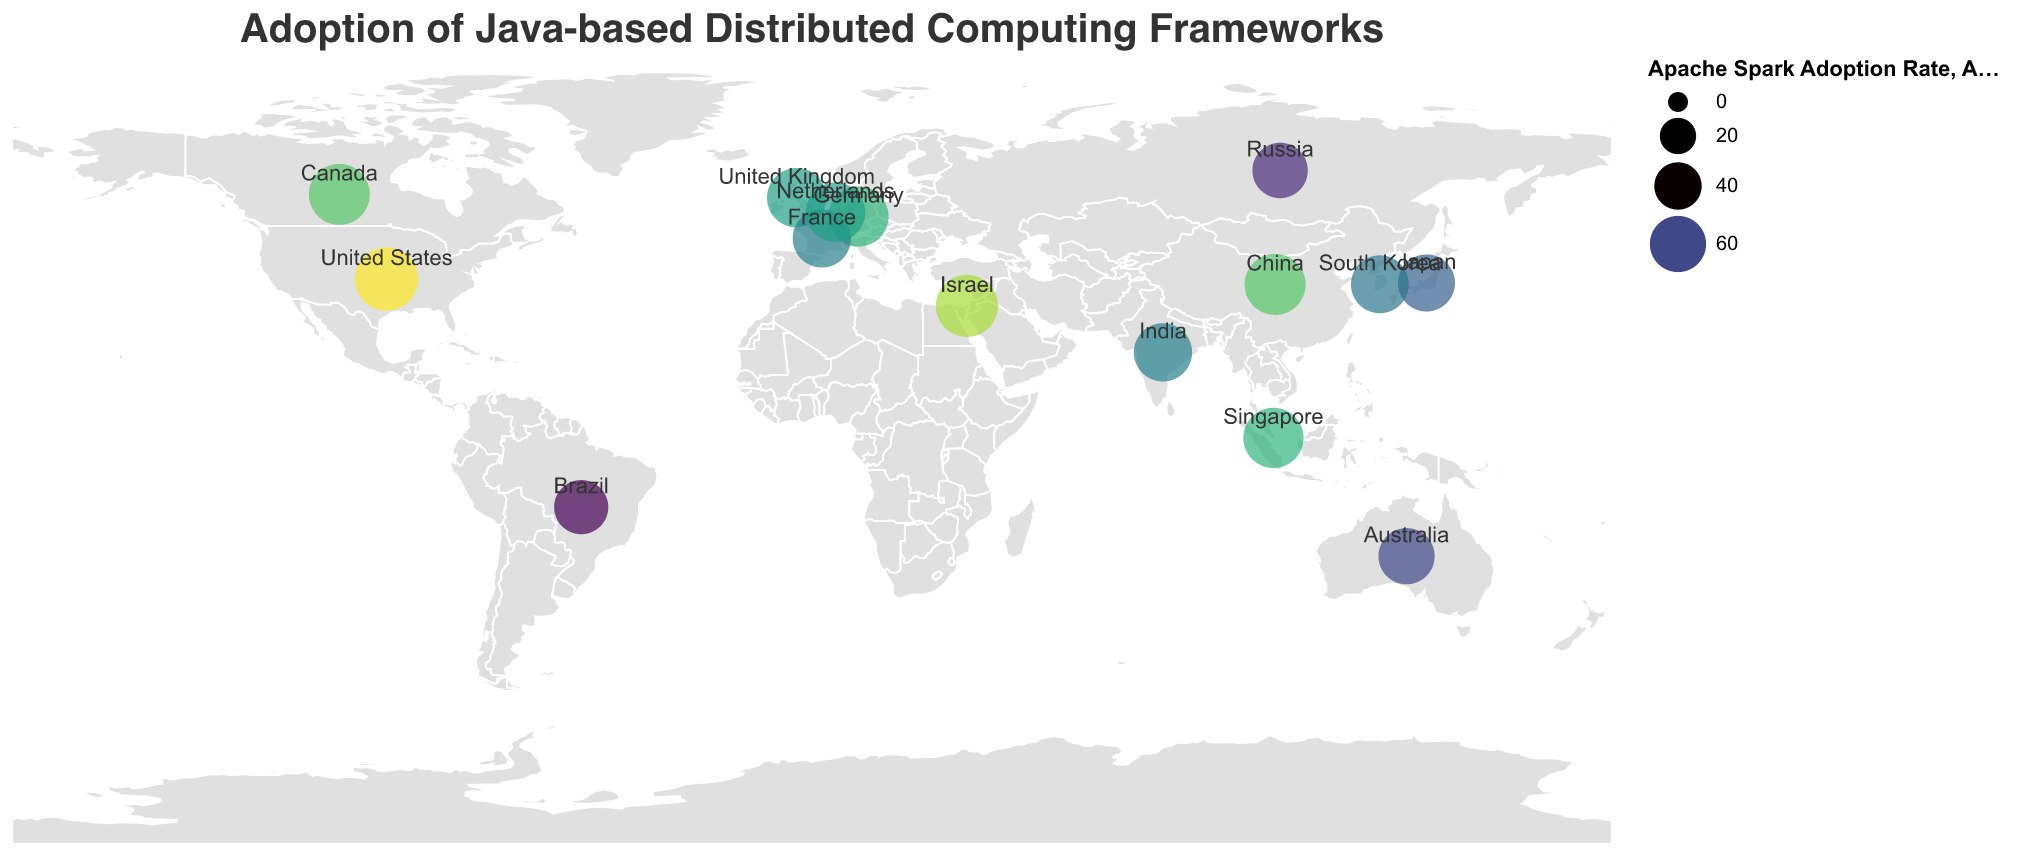What is the title of the figure? The title of the figure is displayed at the top and it reads "Adoption of Java-based Distributed Computing Frameworks".
Answer: Adoption of Java-based Distributed Computing Frameworks Which country has the highest adoption rate of Apache Spark? The country with the highest value represented by the largest circle size and the darkest color in the legend for Apache Spark is visible. The value is 78 for the United States.
Answer: United States What is the average adoption rate of Alluxio across all listed countries? Sum the Alluxio adoption rates for all countries and divide by the number of countries. Calculation: (25 + 30 + 22 + 28 + 20 + 18 + 15 + 22 + 24 + 18 + 26 + 20 + 24 + 20 + 28) / 15 = 340 / 15 = 22.67.
Answer: 22.67 Which two countries have the same adoption rate for Apache Storm? By looking at the numerical labels on the figure, United Kingdom and China both have a value of 38 for Apache Storm.
Answer: United Kingdom and China What is the difference between the highest and the lowest adoption rates of Apache Hadoop? Identify the highest value (China, 70) and the lowest value (France, 52) from the figure, then calculate the difference: 70 - 52 = 18.
Answer: 18 Which country has a higher adoption rate of Apache Flink, Germany or Australia? By comparing the numerical values provided on the figure for respective countries, Germany has 48 and Australia has 28. Germany has a higher adoption.
Answer: Germany What is the total adoption rate of Apache Spark for the countries in Asia listed in the data? Sum the Apache Spark adoption rates for China, India, Japan, Singapore, and South Korea. Calculation: 72 + 65 + 62 + 70 + 64 = 333.
Answer: 333 Is the adoption rate of Alluxio more than 20 in Canada? From the figure, the adoption rate of Alluxio in Canada is shown as 22, which is indeed greater than 20.
Answer: Yes Which country has the lowest adoption rate of Apache Flink and what is its value? By observing the numerical values for Apache Flink, the lowest number is for Japan, with a value of 28.
Answer: Japan, 28 How does the adoption rate of Apache Spark in Brazil compare to that in France? Observe the Apache Spark values for both countries, Brazil has 55 and France has 65. France has a higher adoption rate than Brazil.
Answer: France has a higher adoption rate 